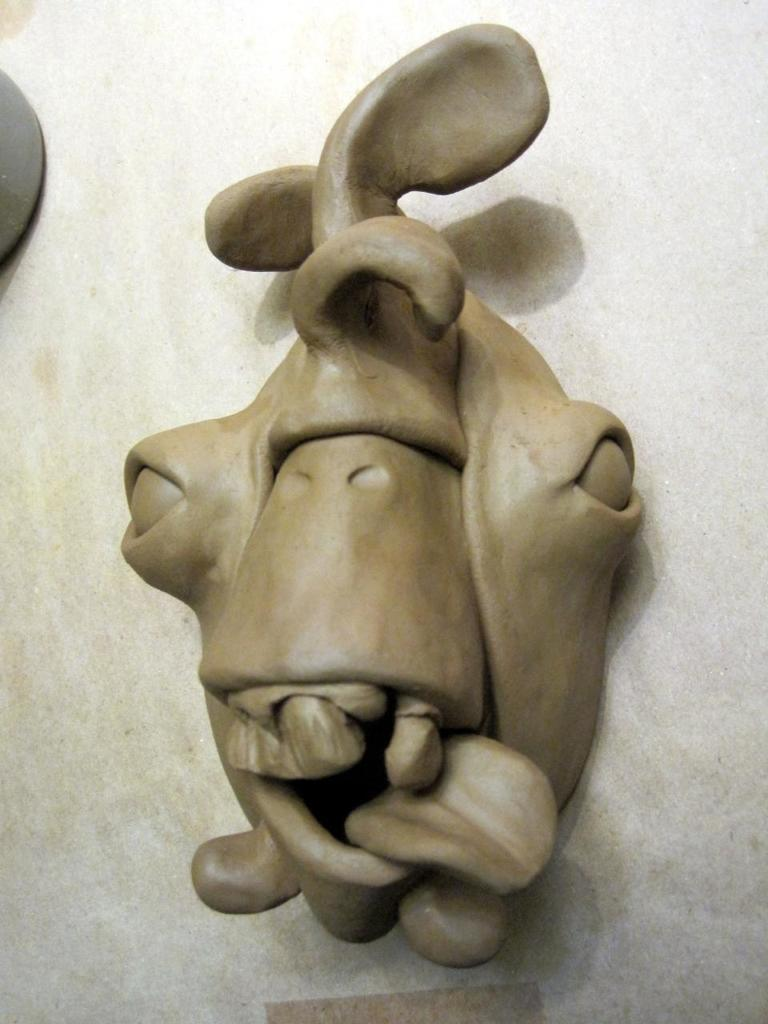What is the name of the van that is connected to the wire in the image? There is no van or wire present in the image, so it is not possible to answer that question. 